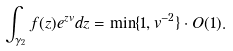Convert formula to latex. <formula><loc_0><loc_0><loc_500><loc_500>\int _ { \gamma _ { 2 } } f ( z ) e ^ { z v } d z = \min \{ 1 , v ^ { - 2 } \} \cdot O ( 1 ) .</formula> 